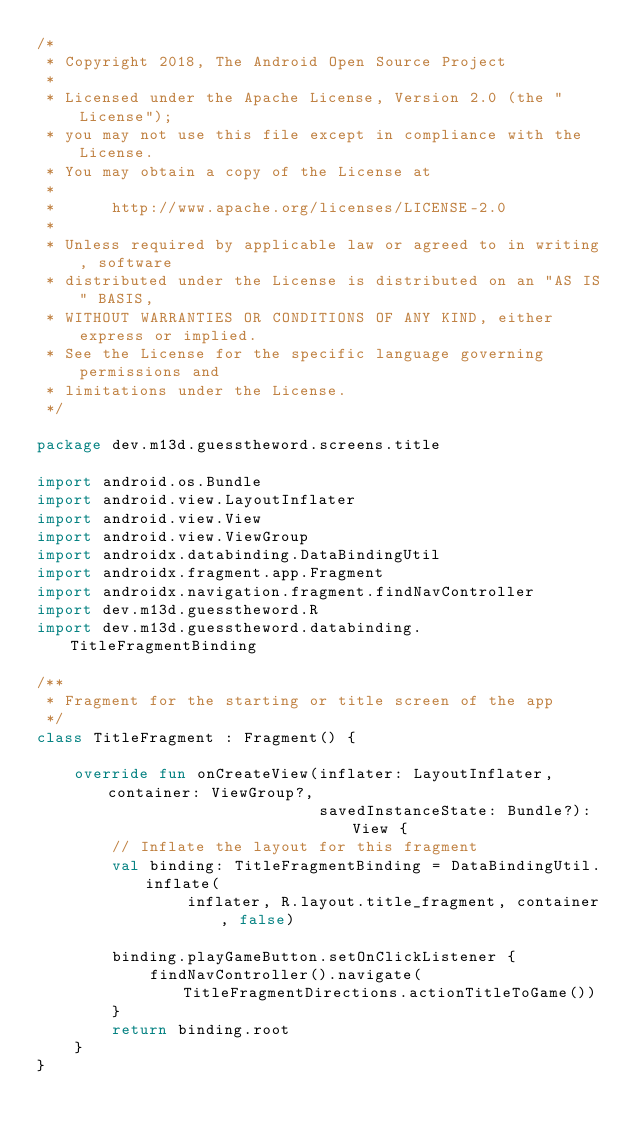Convert code to text. <code><loc_0><loc_0><loc_500><loc_500><_Kotlin_>/*
 * Copyright 2018, The Android Open Source Project
 *
 * Licensed under the Apache License, Version 2.0 (the "License");
 * you may not use this file except in compliance with the License.
 * You may obtain a copy of the License at
 *
 *      http://www.apache.org/licenses/LICENSE-2.0
 *
 * Unless required by applicable law or agreed to in writing, software
 * distributed under the License is distributed on an "AS IS" BASIS,
 * WITHOUT WARRANTIES OR CONDITIONS OF ANY KIND, either express or implied.
 * See the License for the specific language governing permissions and
 * limitations under the License.
 */

package dev.m13d.guesstheword.screens.title

import android.os.Bundle
import android.view.LayoutInflater
import android.view.View
import android.view.ViewGroup
import androidx.databinding.DataBindingUtil
import androidx.fragment.app.Fragment
import androidx.navigation.fragment.findNavController
import dev.m13d.guesstheword.R
import dev.m13d.guesstheword.databinding.TitleFragmentBinding

/**
 * Fragment for the starting or title screen of the app
 */
class TitleFragment : Fragment() {

    override fun onCreateView(inflater: LayoutInflater, container: ViewGroup?,
                              savedInstanceState: Bundle?): View {
        // Inflate the layout for this fragment
        val binding: TitleFragmentBinding = DataBindingUtil.inflate(
                inflater, R.layout.title_fragment, container, false)

        binding.playGameButton.setOnClickListener {
            findNavController().navigate(TitleFragmentDirections.actionTitleToGame())
        }
        return binding.root
    }
}
</code> 